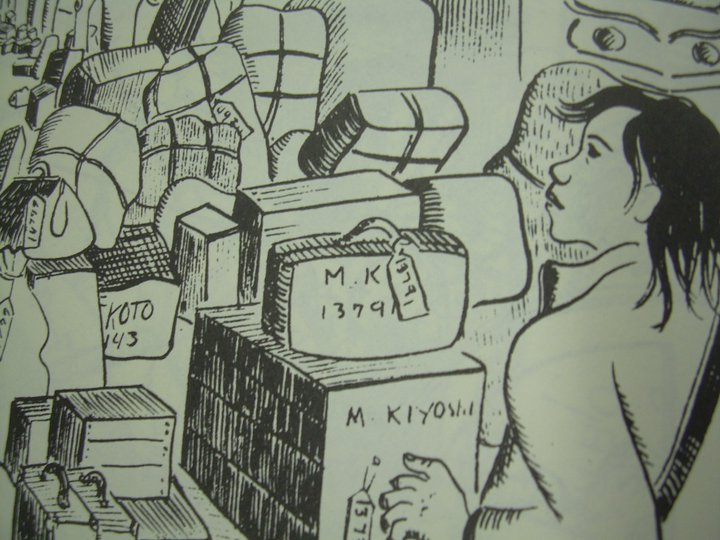Can you explore the emotional context this image might represent? Certainly. The woman's subdued expression and the plethora of personal belongings around her might represent a moment of transition or loss. Her posture and serene but distant expression could suggest that she is reminiscing or perhaps reconsidering decisions about moving forward or leaving something behind. The packed nature of the items, coupled with their personal markings, underscores a narrative of departure or change, laden with emotional weight and the melancholy of departure or the quiet hope embedded in new beginnings. 